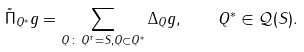Convert formula to latex. <formula><loc_0><loc_0><loc_500><loc_500>\tilde { \Pi } _ { Q ^ { \ast } } g = \sum _ { Q \, \colon \, Q ^ { \tau } = S , Q \subset Q ^ { \ast } } \Delta _ { Q } g , \quad Q ^ { \ast } \in \mathcal { Q } ( S ) .</formula> 